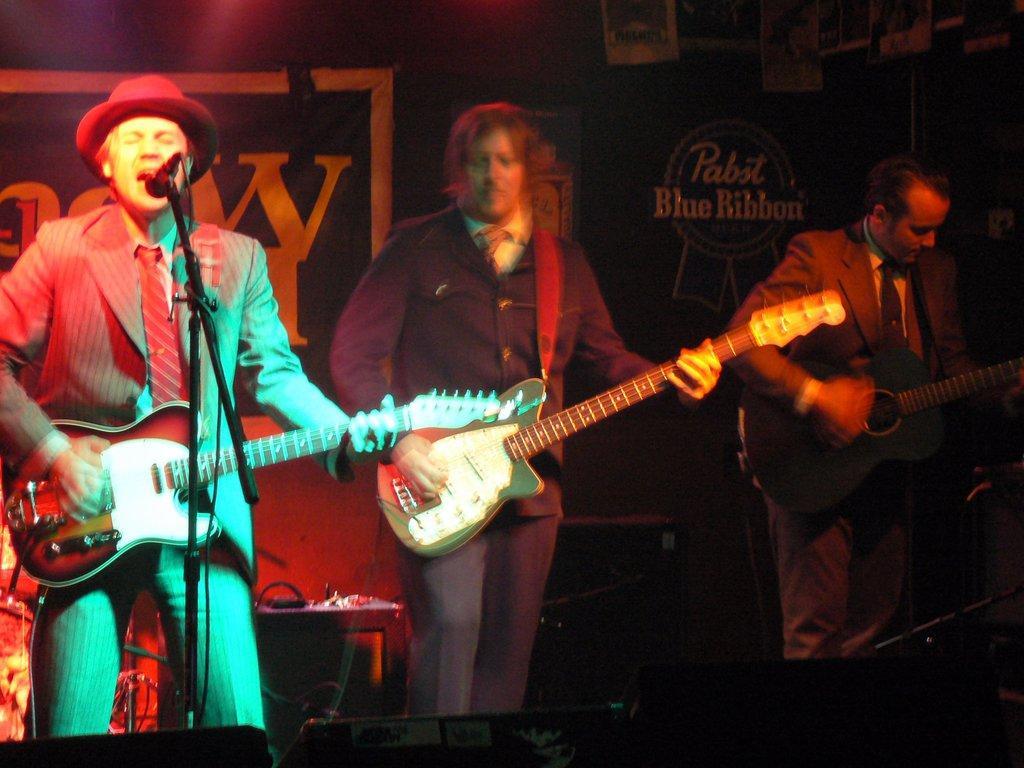Please provide a concise description of this image. In this picture we can see three men playing guitars and here man singing on mic and in background we can see wall with banners, table. 